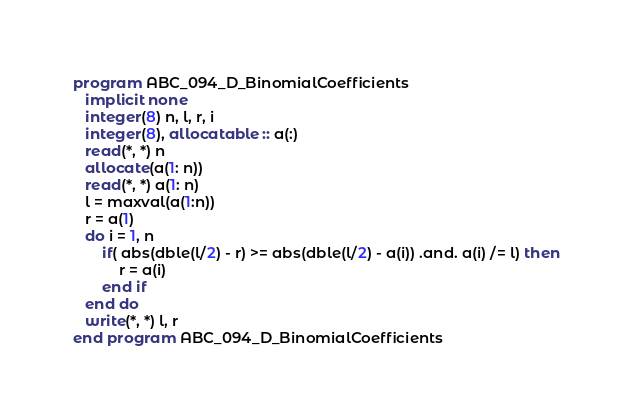<code> <loc_0><loc_0><loc_500><loc_500><_FORTRAN_>program ABC_094_D_BinomialCoefficients
   implicit none
   integer(8) n, l, r, i
   integer(8), allocatable :: a(:)
   read(*, *) n
   allocate(a(1: n))
   read(*, *) a(1: n)
   l = maxval(a(1:n))
   r = a(1)
   do i = 1, n
       if( abs(dble(l/2) - r) >= abs(dble(l/2) - a(i)) .and. a(i) /= l) then
	       r = a(i)
	   end if
   end do
   write(*, *) l, r 
end program ABC_094_D_BinomialCoefficients</code> 